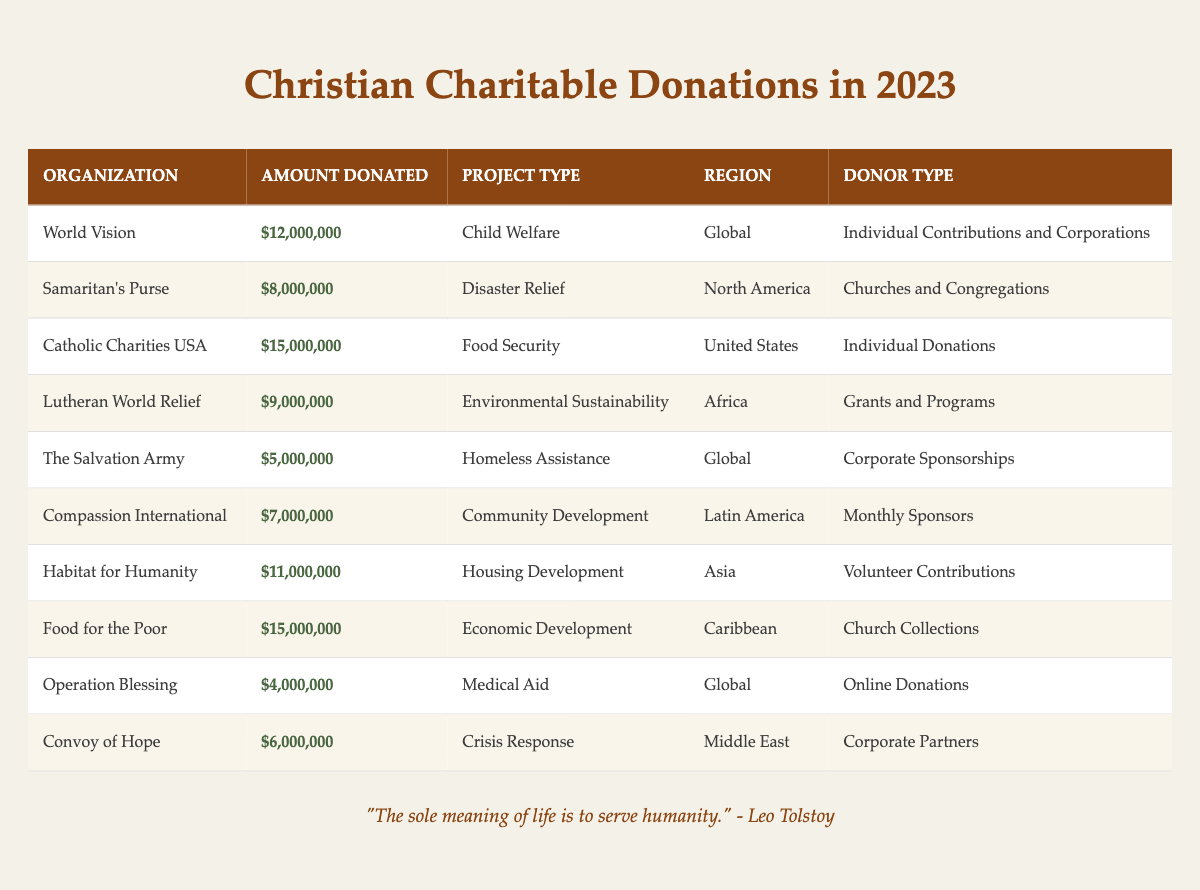What is the total amount donated by "Catholic Charities USA"? The table shows that "Catholic Charities USA" donated $15,000,000 in 2023.
Answer: $15,000,000 Which organization donated the least amount in 2023? In the table, "Operation Blessing" is listed as having donated $4,000,000, which is the smallest amount compared to other organizations.
Answer: $4,000,000 What is the combined total donation amount from organizations focused on food security and economic development? "Catholic Charities USA" donated $15,000,000 for food security, and "Food for the Poor" donated $15,000,000 for economic development. Summing these amounts gives $15,000,000 + $15,000,000 = $30,000,000.
Answer: $30,000,000 How many organizations donated over $10,000,000? The organizations that donated over $10,000,000 are "World Vision" ($12,000,000), "Catholic Charities USA" ($15,000,000), "Food for the Poor" ($15,000,000), and "Habitat for Humanity" ($11,000,000). That makes a total of 4 organizations.
Answer: 4 In which region did "Compassion International" focus its donations? According to the table, "Compassion International" focused its donations on Latin America.
Answer: Latin America Is the donation amount from "The Salvation Army" greater than the combined donations of "Samaritan's Purse" and "Operation Blessing"? "The Salvation Army" donated $5,000,000, while "Samaritan's Purse" donated $8,000,000 and "Operation Blessing" donated $4,000,000. The combined amount of the latter two is $8,000,000 + $4,000,000 = $12,000,000, which is greater than $5,000,000. Thus, the statement is true.
Answer: Yes What is the average donation amount from all organizations listed? The total amount donated by all organizations is $12,000,000 + $8,000,000 + $15,000,000 + $9,000,000 + $5,000,000 + $7,000,000 + $11,000,000 + $15,000,000 + $4,000,000 + $6,000,000 = $82,000,000. There are 10 organizations, so averaging the total gives $82,000,000 / 10 = $8,200,000.
Answer: $8,200,000 Which organization received donations from monthly sponsors? The table indicates that "Compassion International" received its donations from monthly sponsors.
Answer: Compassion International Did any organization focus on housing development? Yes, according to the table, "Habitat for Humanity" focused on housing development.
Answer: Yes What percentage of the total donations does "Food for the Poor" represent? The total donations amount to $82,000,000, with "Food for the Poor" donating $15,000,000. To find the percentage: ($15,000,000 / $82,000,000) × 100 = 18.29%. Therefore, "Food for the Poor" represents approximately 18.29% of total donations.
Answer: 18.29% 